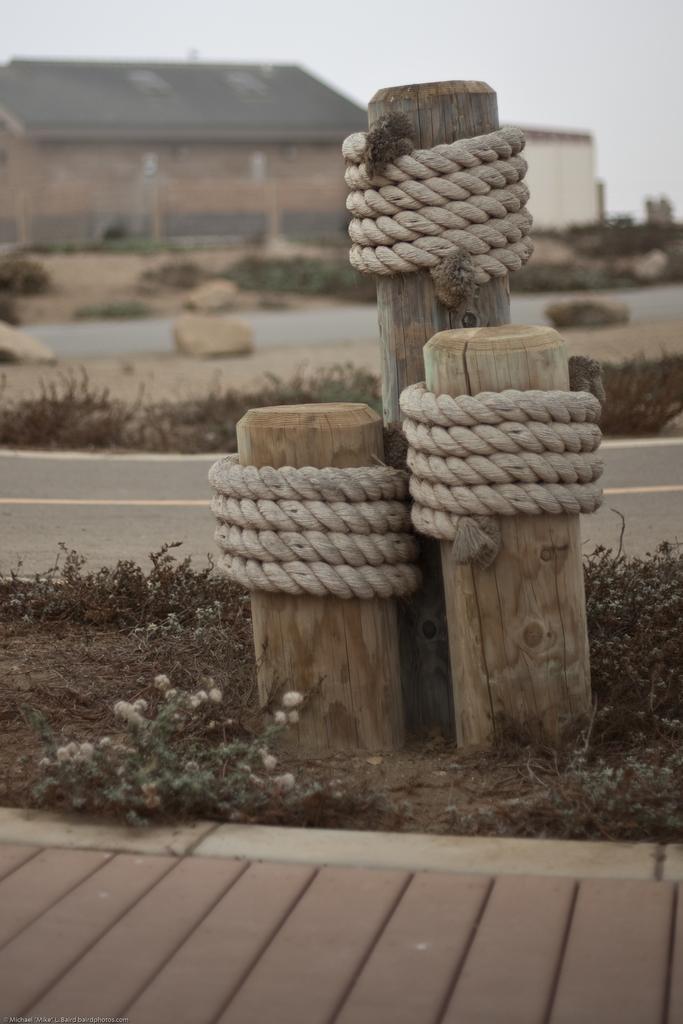Describe this image in one or two sentences. At the bottom of the image there is a floor. Behind the floor there is grass and also there are wooden logs with ropes. Behind them there is a road. In the background on the ground there are stones. And also there are buildings with roofs and walls. 